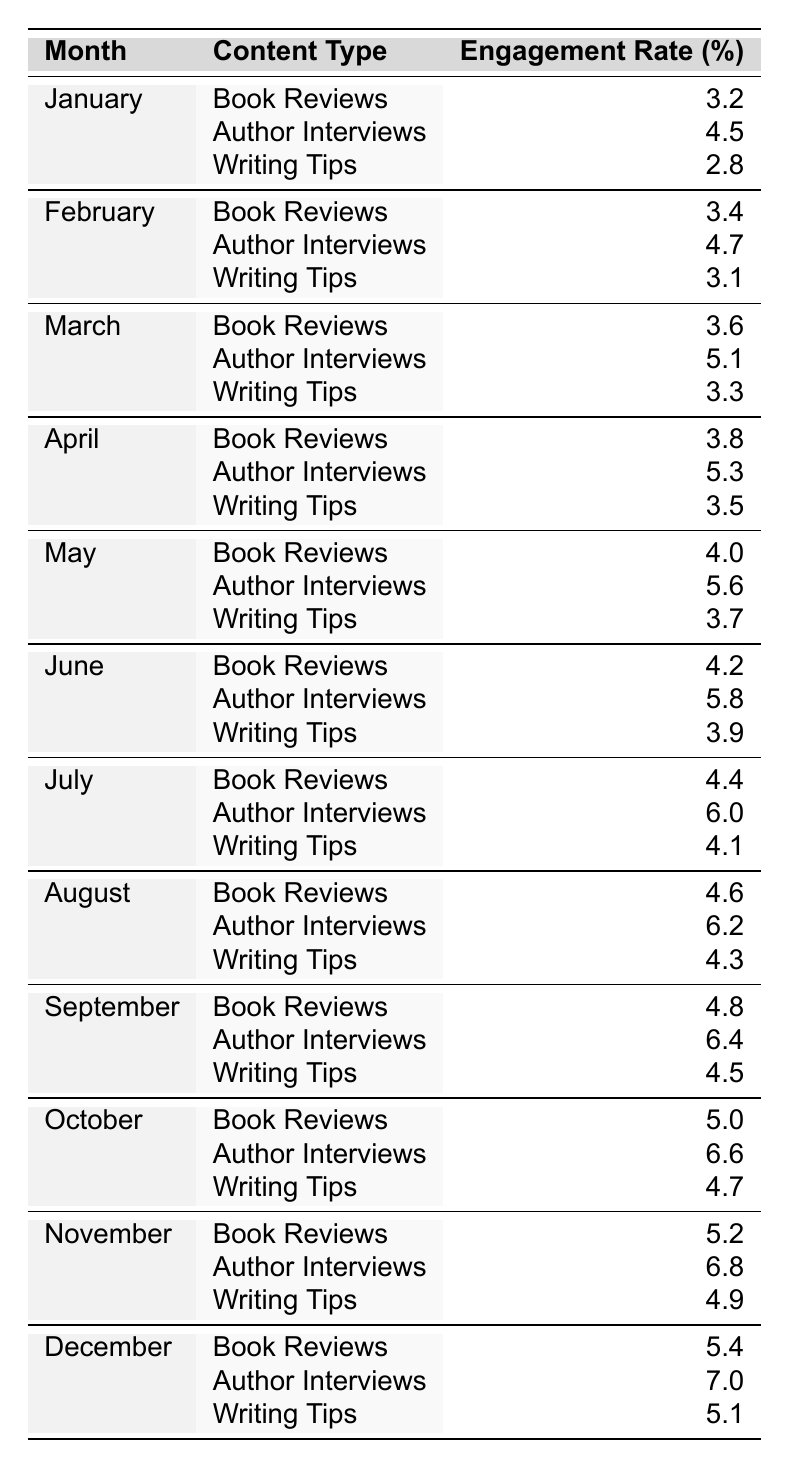What's the engagement rate for Author Interviews in December? The table shows that for December, the engagement rate for Author Interviews is listed directly as 7.0%.
Answer: 7.0 What was the highest engagement rate for Writing Tips in a month? By reviewing the table, the highest engagement rate for Writing Tips was 5.1%, which occurred in December.
Answer: 5.1 Which month had the lowest engagement rate for Book Reviews? Looking through the table, January has the lowest engagement rate for Book Reviews at 3.2%.
Answer: January What is the average engagement rate for Author Interviews over the year? To find the average, sum all the engagement rates for Author Interviews (4.5 + 4.7 + 5.1 + 5.3 + 5.6 + 5.8 + 6.0 + 6.2 + 6.4 + 6.6 + 6.8 + 7.0 = 68.6), then divide by 12 (68.6/12 ≈ 5.72).
Answer: 5.72 Did Writing Tips engage more audience in the second half of the year compared to the first half? By comparing the average engagement rates: first half (January to June: 3.5) and second half (July to December: 4.5). Since 4.5 is greater than 3.5, Writing Tips did engage more in the second half.
Answer: Yes How does the engagement rate for Author Interviews in October compare to that in April? The engagement rate for Author Interviews in October is 6.6% while in April it is 5.3%. Since 6.6 is greater than 5.3, October had a higher engagement rate.
Answer: Higher What was the overall increase in engagement rate for Book Reviews from January to December? The engagement rate for Book Reviews in January was 3.2%, and in December, it was 5.4%. The increase is calculated as (5.4 - 3.2) = 2.2 percentage points.
Answer: 2.2 What content type consistently had the highest engagement throughout the year? By reviewing the table, Author Interviews consistently had the highest engagement rates compared to Book Reviews and Writing Tips each month.
Answer: Author Interviews In which month did Writing Tips see the greatest increase in engagement compared to the previous month? By calculating the month-to-month changes for Writing Tips, the greatest increase occurred from April (3.5%) to May (3.7%), an increase of 0.2%.
Answer: May Which content type had a consistent upward trend across all months? Analyzing the data, Author Interviews consistently increased each month throughout the year, showing an upward trend.
Answer: Author Interviews 